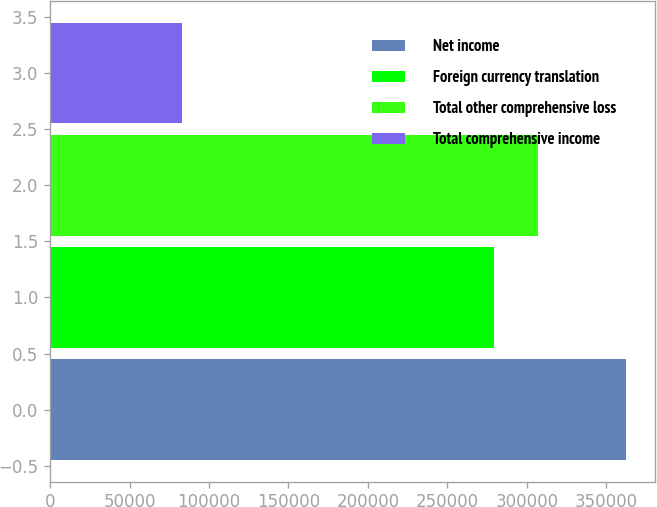Convert chart to OTSL. <chart><loc_0><loc_0><loc_500><loc_500><bar_chart><fcel>Net income<fcel>Foreign currency translation<fcel>Total other comprehensive loss<fcel>Total comprehensive income<nl><fcel>362431<fcel>279303<fcel>307233<fcel>83128<nl></chart> 